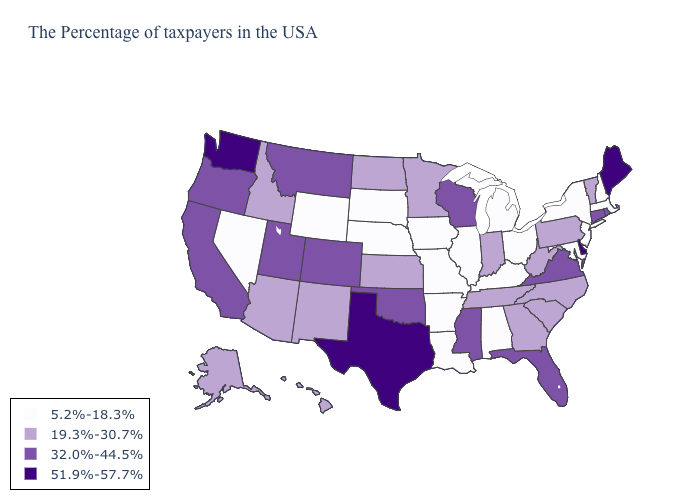What is the highest value in the USA?
Short answer required. 51.9%-57.7%. What is the highest value in the MidWest ?
Answer briefly. 32.0%-44.5%. What is the highest value in the USA?
Answer briefly. 51.9%-57.7%. Name the states that have a value in the range 32.0%-44.5%?
Short answer required. Rhode Island, Connecticut, Virginia, Florida, Wisconsin, Mississippi, Oklahoma, Colorado, Utah, Montana, California, Oregon. Name the states that have a value in the range 51.9%-57.7%?
Give a very brief answer. Maine, Delaware, Texas, Washington. Among the states that border Texas , which have the lowest value?
Give a very brief answer. Louisiana, Arkansas. Does Pennsylvania have the same value as New York?
Concise answer only. No. Does the map have missing data?
Concise answer only. No. What is the value of Oregon?
Write a very short answer. 32.0%-44.5%. What is the highest value in the USA?
Write a very short answer. 51.9%-57.7%. Among the states that border Washington , does Oregon have the highest value?
Be succinct. Yes. Does Washington have the highest value in the West?
Quick response, please. Yes. What is the lowest value in the West?
Write a very short answer. 5.2%-18.3%. Does the first symbol in the legend represent the smallest category?
Answer briefly. Yes. What is the value of Connecticut?
Short answer required. 32.0%-44.5%. 